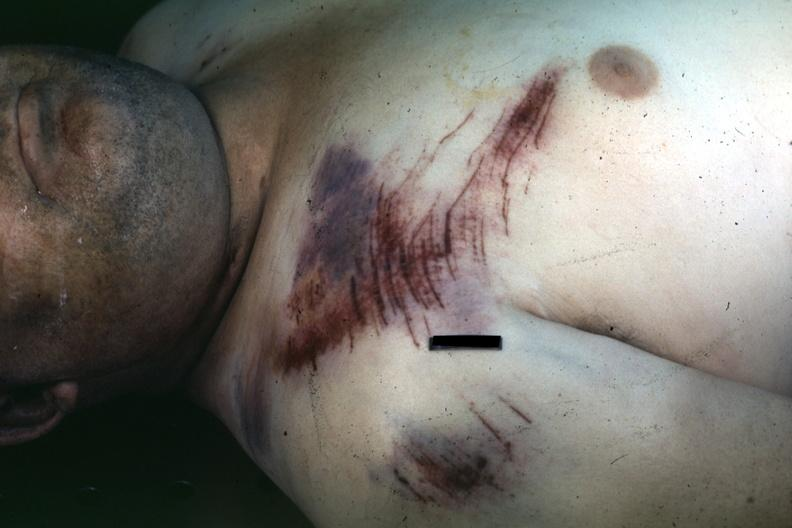where is this?
Answer the question using a single word or phrase. Skin 